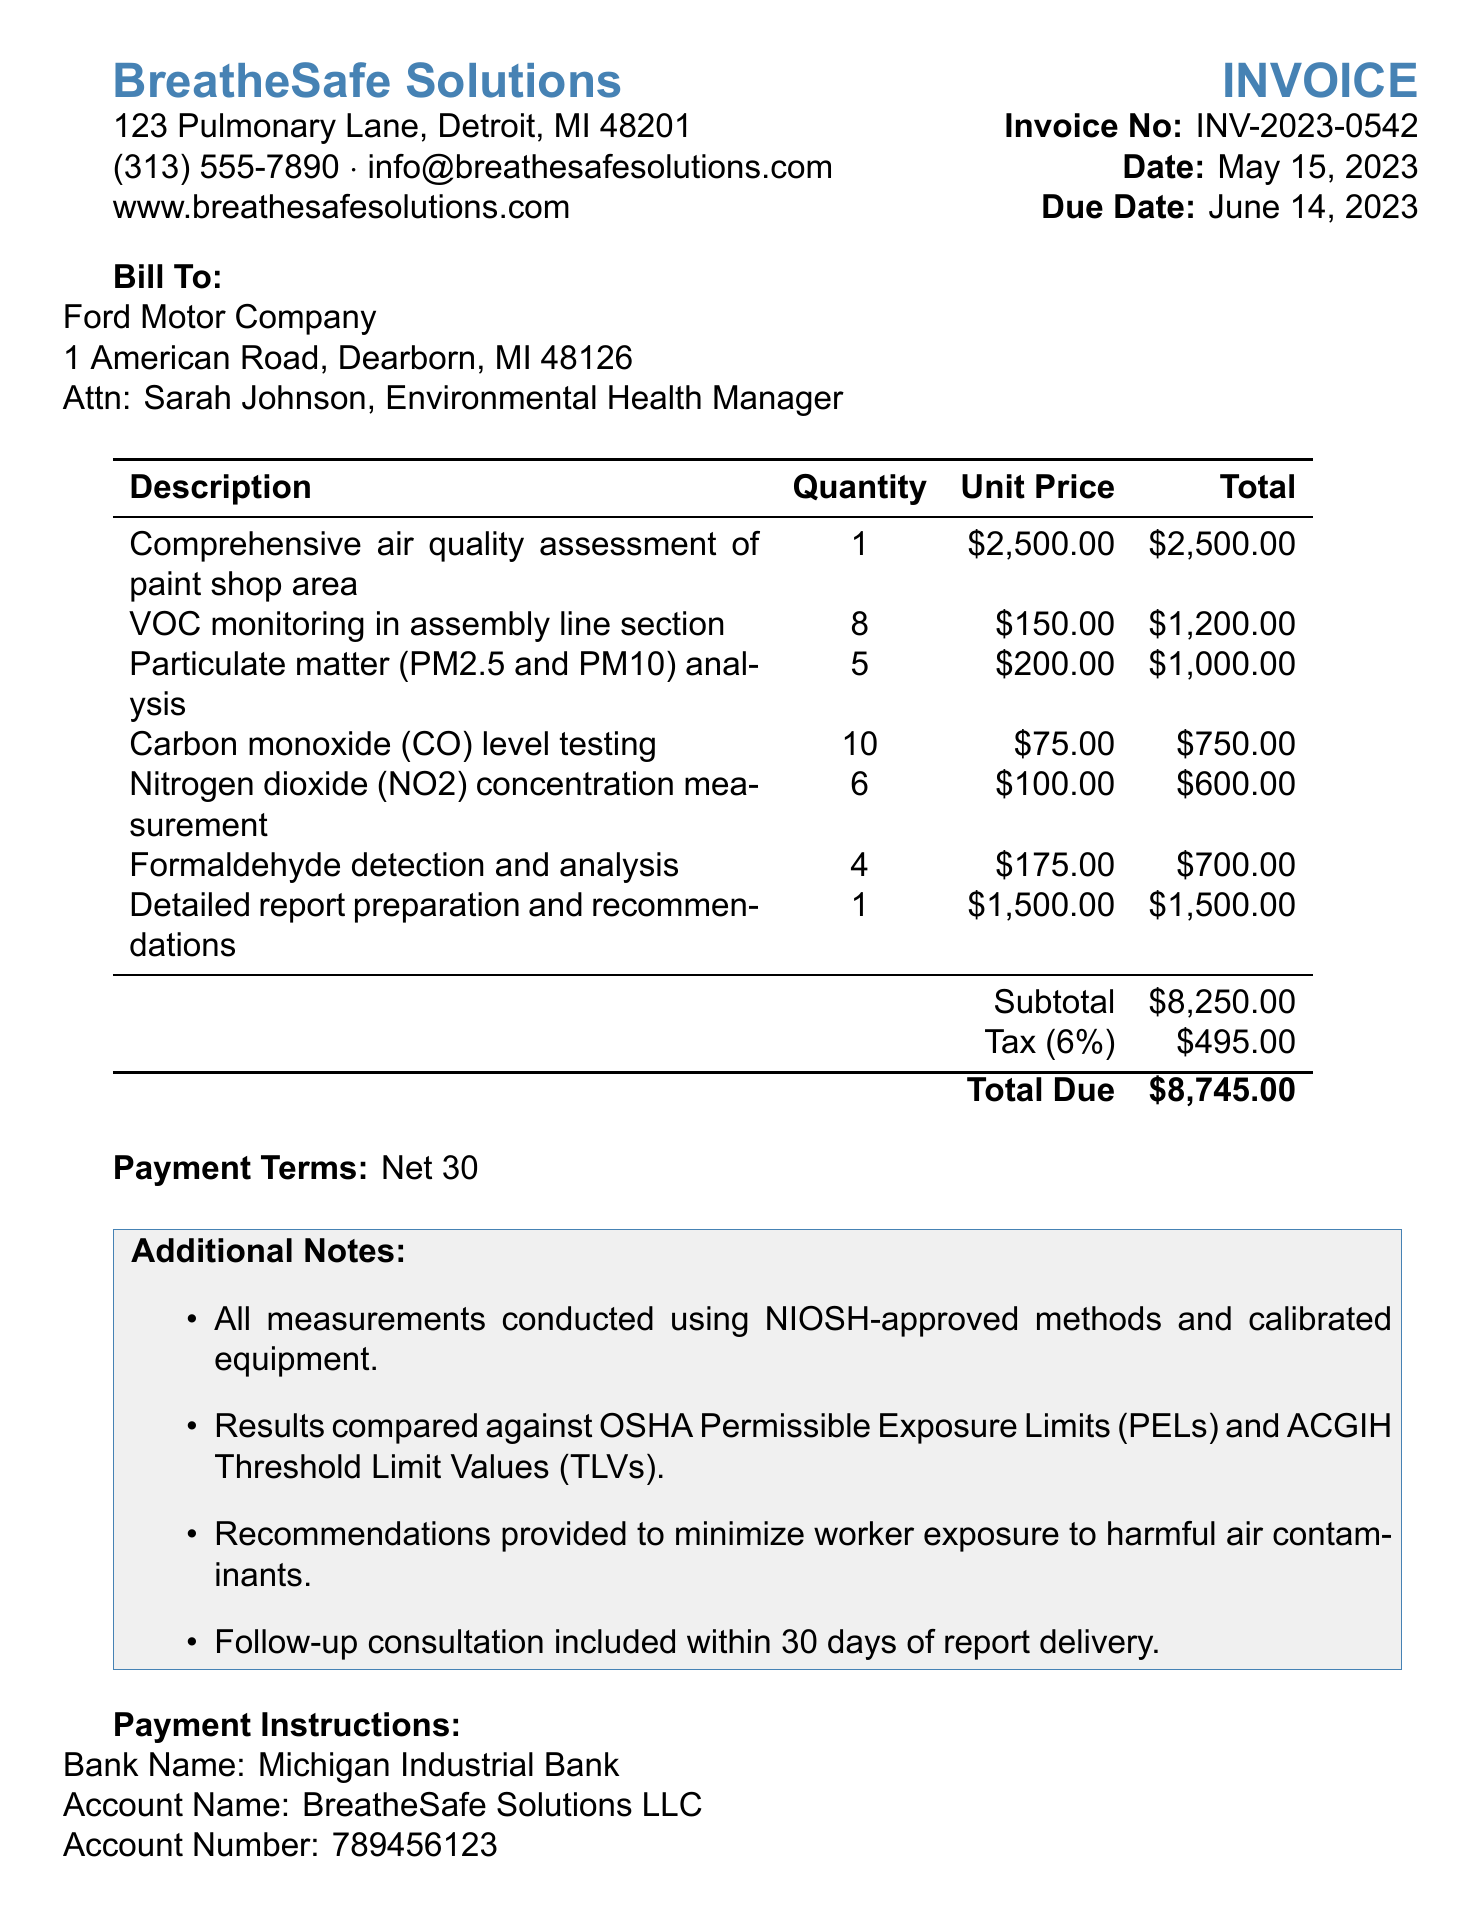What is the name of the company providing the services? The company providing the services is listed at the top of the document, which is BreatheSafe Solutions.
Answer: BreatheSafe Solutions What is the invoice number? The invoice number is specifically mentioned in the document under invoice details as INV-2023-0542.
Answer: INV-2023-0542 When is the payment due? The due date for the payment is indicated in the invoice details and is June 14, 2023.
Answer: June 14, 2023 What is the total amount due? The total amount due is found at the bottom of the invoice, which totals to $8745.00.
Answer: $8745.00 How much was charged for VOC monitoring? The amount charged for VOC monitoring is clearly stated in the services section as $1200.00.
Answer: $1200.00 What kind of certifications are listed? The document lists certifications in the footer section, which includes Certified Respiratory Therapist (CRT), Registered Respiratory Therapist (RRT), and Certified Indoor Air Quality Professional (CIAQP).
Answer: Certified Respiratory Therapist (CRT), Registered Respiratory Therapist (RRT), Certified Indoor Air Quality Professional (CIAQP) What payment terms are specified in the invoice? The invoice specifies the payment terms as Net 30.
Answer: Net 30 What is included in the additional notes? The additional notes provide information about the methods used and the recommendations provided, highlighting the use of NIOSH-approved methods and follow-up consultations.
Answer: NIOSH-approved methods and follow-up consultations How many services were provided? The total number of service types listed in the document is counted in the services section, which features seven different services.
Answer: 7 